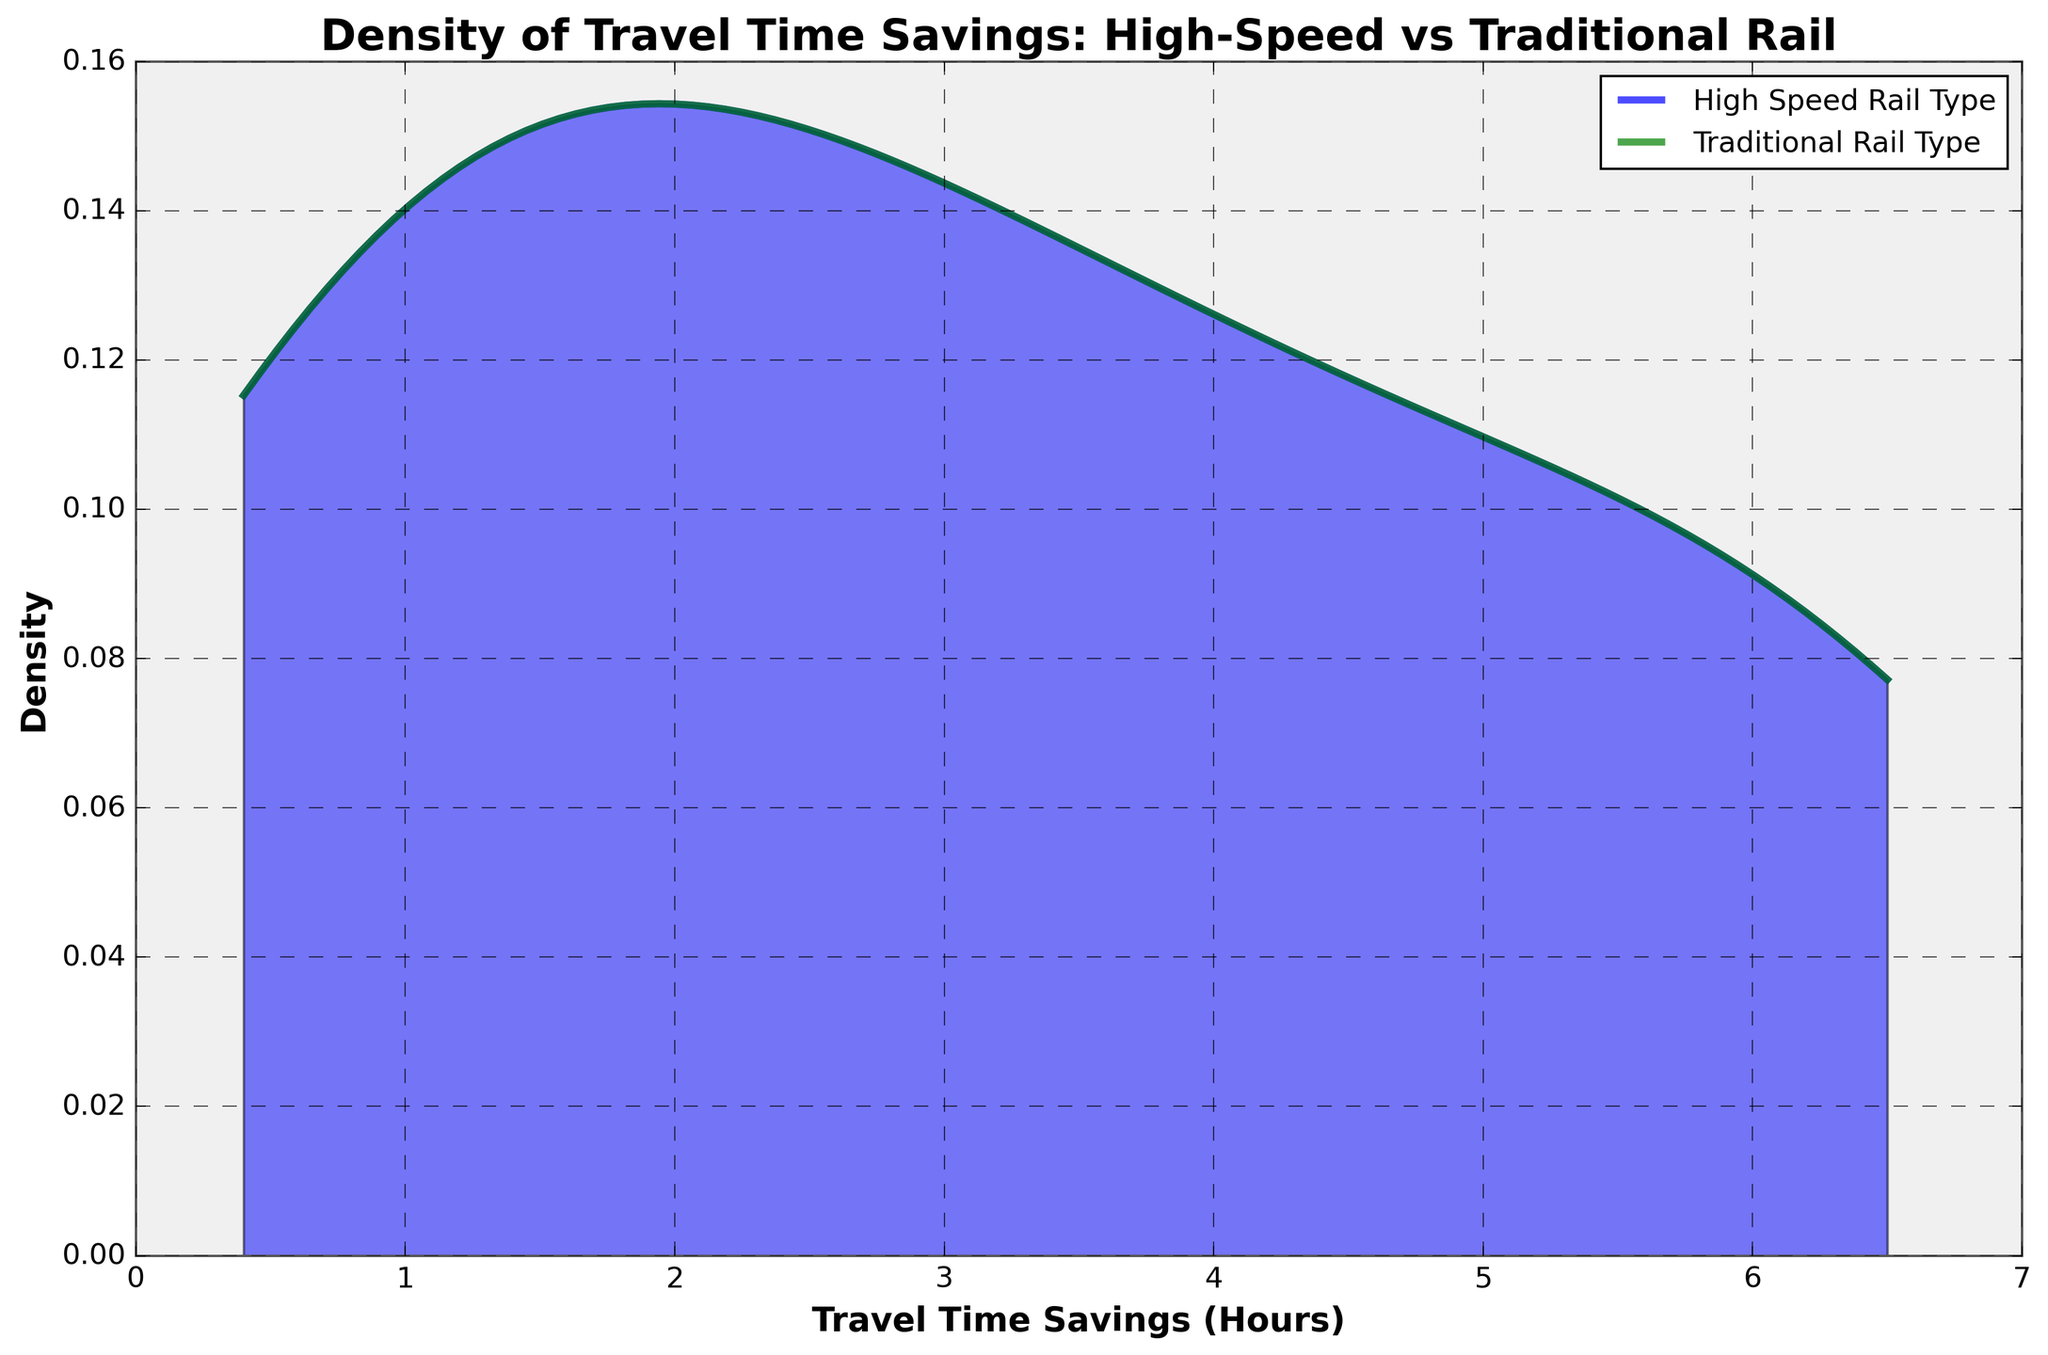What title is displayed on the plot? The title of a plot generally provides a brief description of what the visualization represents. In this case, it indicates the focus is on the density of travel time savings for different rail types. By looking at the title area, we can directly read the text presented there.
Answer: Density of Travel Time Savings: High-Speed vs Traditional Rail What does the x-axis represent? The x-axis of a plot typically labels the variable being measured horizontally. Here, it indicates the specific metric that the density is being calculated for by displaying the label text.
Answer: Travel Time Savings (Hours) Which rail type shows a higher peak in density according to the plot, High-Speed Rail Type or Traditional Rail Type? To determine this, we need to compare the peak heights of each density curve. The rail type with the taller peak represents a higher density.
Answer: Traditional Rail Type Between what two values does the highest density region for High-Speed Rail Type lie? A density plot shows the concentration of data points over a range. The highest density region can be identified by finding the range where the density curve for High-Speed Rail Type reaches its maximum values.
Answer: 0.4 to 6.2 hours Which range has the greatest travel time savings for High-Speed Rail Type? To answer this, we need to look at the segment of the x-axis where the density curve for High-Speed Rail Type reaches the highest value. This indicates where travel time savings are most concentrated.
Answer: 500-700km range Is there any overlap in the density curves for the two rail types? Overlapping density curves suggest that both rail types have travel time savings within similar ranges. Observing both curves in the plot will provide the answer.
Answer: Yes How does the shape of the density curve for High-Speed Rail Type compare to that of Traditional Rail Type? This question requires an examination of the overall shapes of the density curves. The difference in the breadth, peaks, and spread of each curve provides insights into their comparative shapes.
Answer: The High-Speed Rail Type curve is more spread out and has more distinct peaks Within the 100-200km range, which rail type shows a higher density? Analyzing the height of the density curves within this specific range will reveal which rail type has a higher concentration of travel time savings.
Answer: Traditional Rail Type What's the difference between the peak densities of the two rail types? Identify the peak density value for both High-Speed Rail Type and Traditional Rail Type, then subtract the smaller peak value from the larger one to get the difference.
Answer: The specific values for the peaks need to be known, but Traditional Rail Type has a higher peak Between High-Speed Rail Type and Traditional Rail Type, which one shows a greater spread in travel time savings? A greater spread in travel time savings indicates that the density curve covers a wider range of the x-axis. Observing the spread of each curve will determine which rail type has a greater variation in travel time savings.
Answer: High-Speed Rail Type 